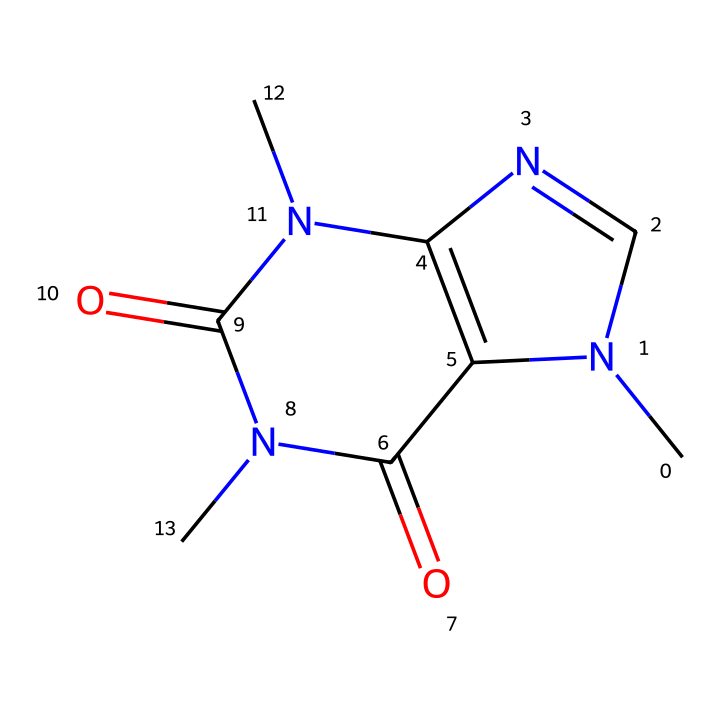What is the molecular formula of caffeine? To find the molecular formula, we count the atoms represented in the SMILES notation. The structure contains 8 carbon (C) atoms, 10 hydrogen (H) atoms, 4 nitrogen (N) atoms, and 2 oxygen (O) atoms. Thus, the formula is C8H10N4O2.
Answer: C8H10N4O2 How many rings are present in the molecular structure of caffeine? By examining the SMILES representation, we identify the cyclic portions of the structure. The molecule contains two fused rings and does not show any additional ring structures attached. Thus, the total number of rings is 2.
Answer: 2 What is the significance of the nitrogen atoms in caffeine? The nitrogen atoms in caffeine are indicative of its classification as an alkaloid, which often has physiological effects. Caffeine has three nitrogen atoms involved in pyrimidine and imidazole ring structures, contributing to its stimulant properties.
Answer: alkaloid What type of chemical is caffeine classified as? Caffeine is classified as a stimulant and falls under the category of methylxanthines. It also belongs to the broader group of psychoactive drugs since it affects the central nervous system, enhancing alertness.
Answer: stimulant Which functional groups are present in caffeine? Caffeine contains two carbonyl groups (C=O) and nitrogen atoms along with methyl (CH3) groups. The combination of these groups contributes to its properties and effects on the body.
Answer: carbonyl and methyl groups 